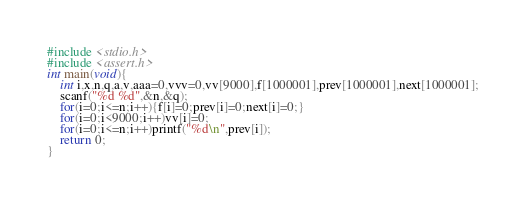<code> <loc_0><loc_0><loc_500><loc_500><_C_>#include <stdio.h>
#include <assert.h>
int main(void){
	int i,x,n,q,a,v,aaa=0,vvv=0,vv[9000],f[1000001],prev[1000001],next[1000001];
	scanf("%d %d",&n,&q);
	for(i=0;i<=n;i++){f[i]=0;prev[i]=0;next[i]=0;}
	for(i=0;i<9000;i++)vv[i]=0;
	for(i=0;i<=n;i++)printf("%d\n",prev[i]);
	return 0;
}</code> 